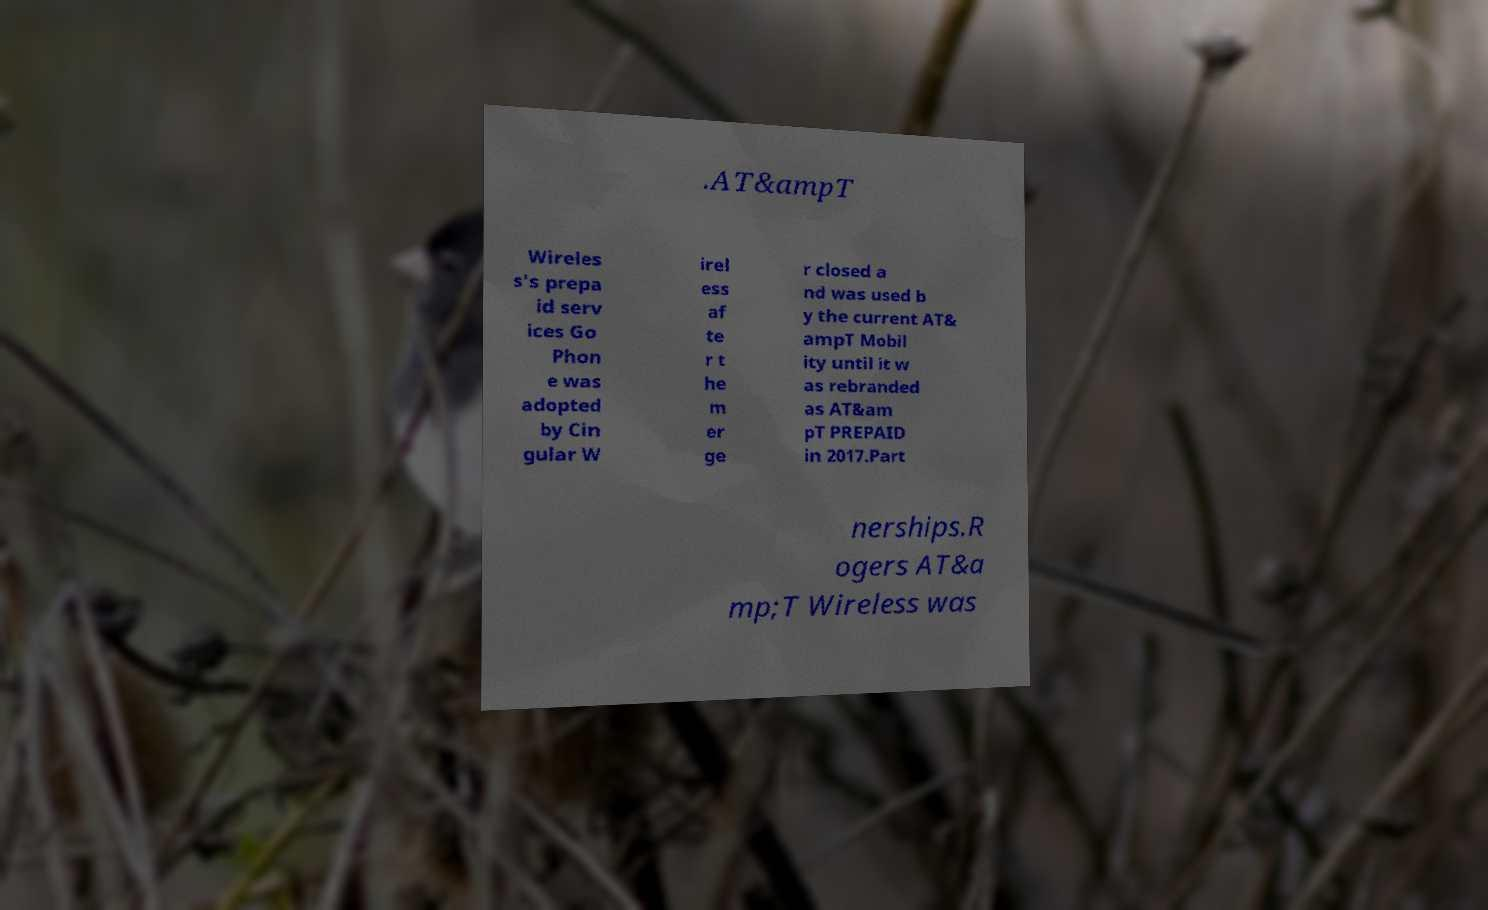For documentation purposes, I need the text within this image transcribed. Could you provide that? .AT&ampT Wireles s's prepa id serv ices Go Phon e was adopted by Cin gular W irel ess af te r t he m er ge r closed a nd was used b y the current AT& ampT Mobil ity until it w as rebranded as AT&am pT PREPAID in 2017.Part nerships.R ogers AT&a mp;T Wireless was 